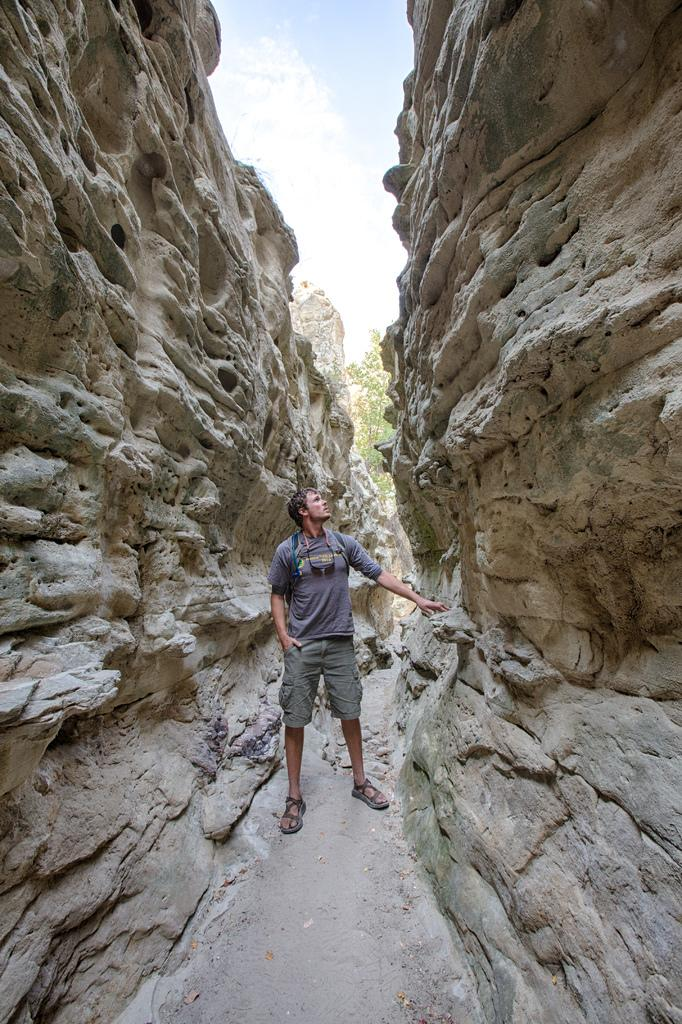What is the main subject of the image? There is a person standing in the center of the image. What can be seen on the left side of the image? There is a rock on the left side of the image. What can be seen on the right side of the image? There is a rock on the right side of the image. What type of vegetation is visible in the background of the image? There is a tree in the background of the image. What type of record is being played in the image? There is no record or music player present in the image. 